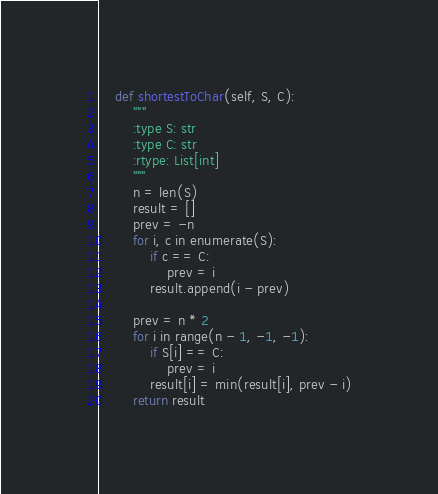<code> <loc_0><loc_0><loc_500><loc_500><_Python_>    def shortestToChar(self, S, C):
        """
        :type S: str
        :type C: str
        :rtype: List[int]
        """
        n = len(S)
        result = []
        prev = -n
        for i, c in enumerate(S):
            if c == C:
                prev = i
            result.append(i - prev)
        
        prev = n * 2
        for i in range(n - 1, -1, -1):
            if S[i] == C:
                prev = i
            result[i] = min(result[i], prev - i)
        return result
</code> 